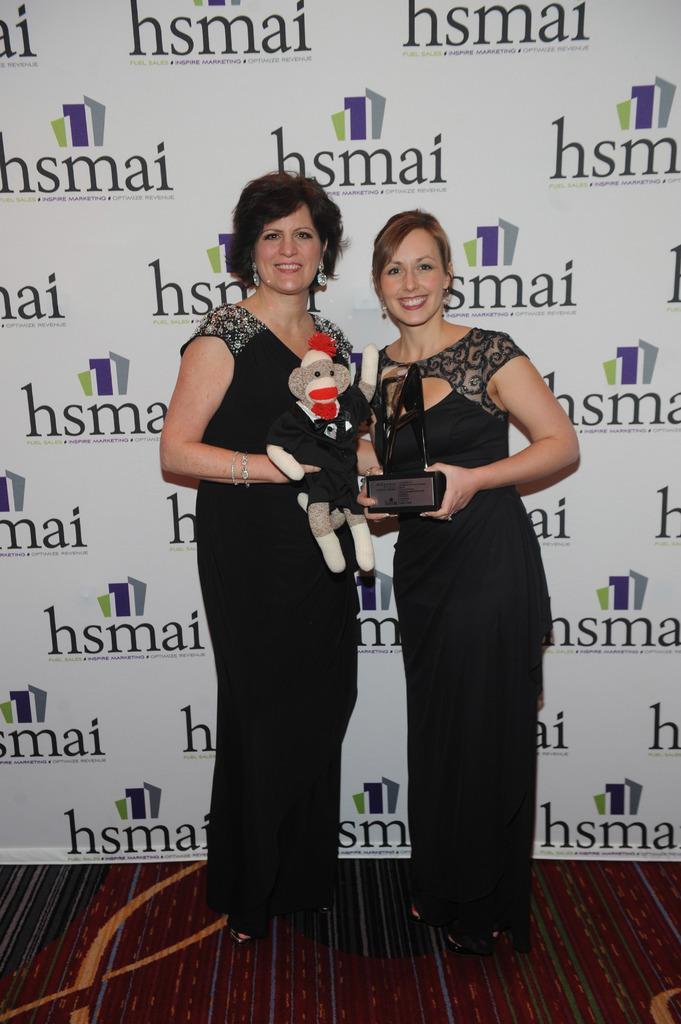Could you give a brief overview of what you see in this image? In the foreground of this image, there are two women standing with a toy and an award on the floor. In the background, there is a banner wall. 